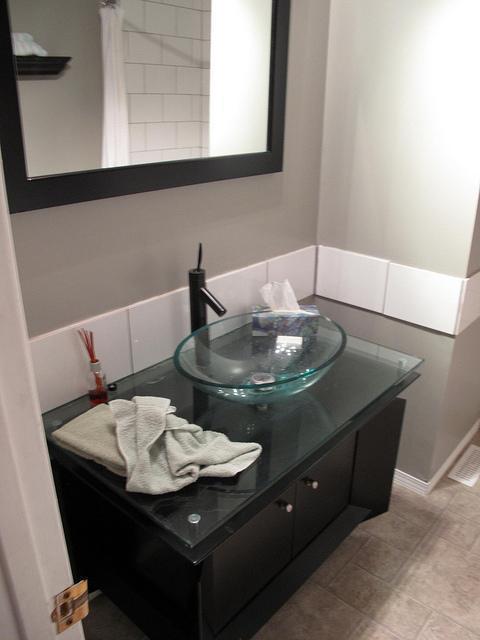How many women are in between the chains of the swing?
Give a very brief answer. 0. 